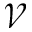Convert formula to latex. <formula><loc_0><loc_0><loc_500><loc_500>\ m a t h s c r { V }</formula> 